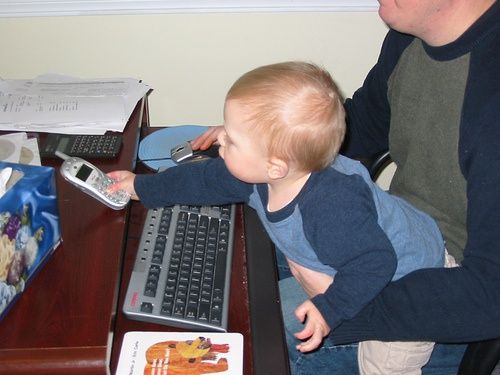Describe the objects in this image and their specific colors. I can see people in lightgray, black, gray, and salmon tones, people in lightgray, darkblue, tan, navy, and gray tones, keyboard in lightgray, gray, and black tones, cell phone in lightgray, darkgray, gray, and black tones, and mouse in lightgray, black, gray, darkgray, and white tones in this image. 